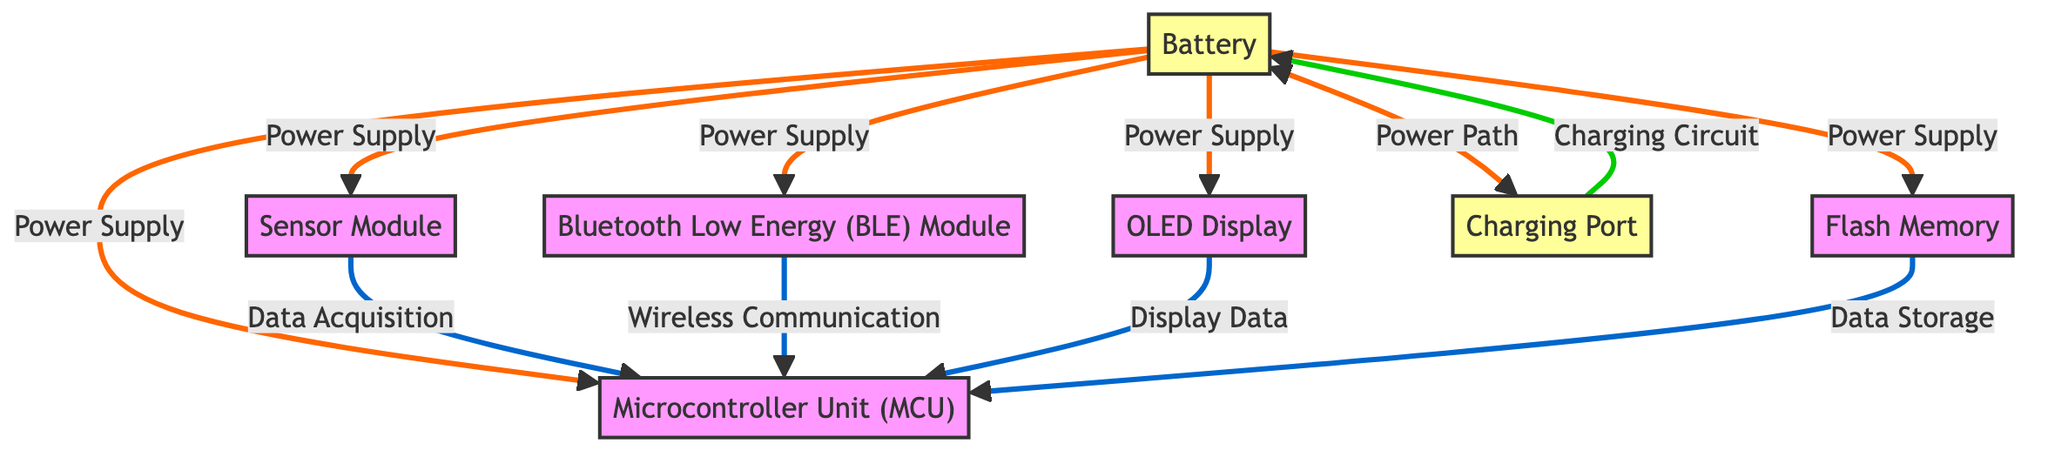What is the primary power source for the components? The diagram indicates that the battery supplies power to all components. There are direct arrows from the battery to the CPU, Sensor, Display, BLE, and Memory, showing the flow of power.
Answer: Battery How many components are connected to the CPU? By examining the diagram, the CPU is connected to four components: the Sensor, BLE, Display, and Memory. Each connection is represented with arrows leading from these components to the CPU.
Answer: Four Which component is responsible for wireless communication? The diagram labels the Bluetooth Low Energy (BLE) module as providing wireless communication. It has an arrow pointing to the CPU, showing its role in the data flow.
Answer: BLE Module What is the relationship between the Charging Port and the Battery? The diagram shows a two-way arrow between the Charging Port and the Battery, indicating that the Charging Port is part of the power path to and from the Battery. The Charging Circuit from the Charging Port also links to the Battery, reinforcing this relationship.
Answer: Power Path Which component has the role of data storage? The Flash Memory component is identified as the data storage unit in the diagram. It has a clear arrow indicating its connection to the CPU for data storage purpose.
Answer: Flash Memory How many total components are illustrated in the diagram? Upon counting the distinct components shown in the diagram, there are six: Microcontroller Unit (MCU), Sensor Module, Battery, OLED Display, Bluetooth Low Energy (BLE) Module, and Flash Memory.
Answer: Six What role does the Sensor Module play in relation to the CPU? The Sensor Module, as indicated by the arrow in the diagram, is responsible for data acquisition, sending data to the CPU for processing. This clearly states its functional relationship with the CPU.
Answer: Data Acquisition Which component connects to the Charging Port? The Charging Port connects to the Battery as per the diagram, with an arrow showing a charged connection. There are no other components linked to the Charging Port in the diagram.
Answer: Battery What type of display is used in the smart wearable device? The OLED Display is specified in the diagram as the type of display used within the smart wearable device. It directly connects to the CPU, indicating its role in the device's functionality.
Answer: OLED Display 